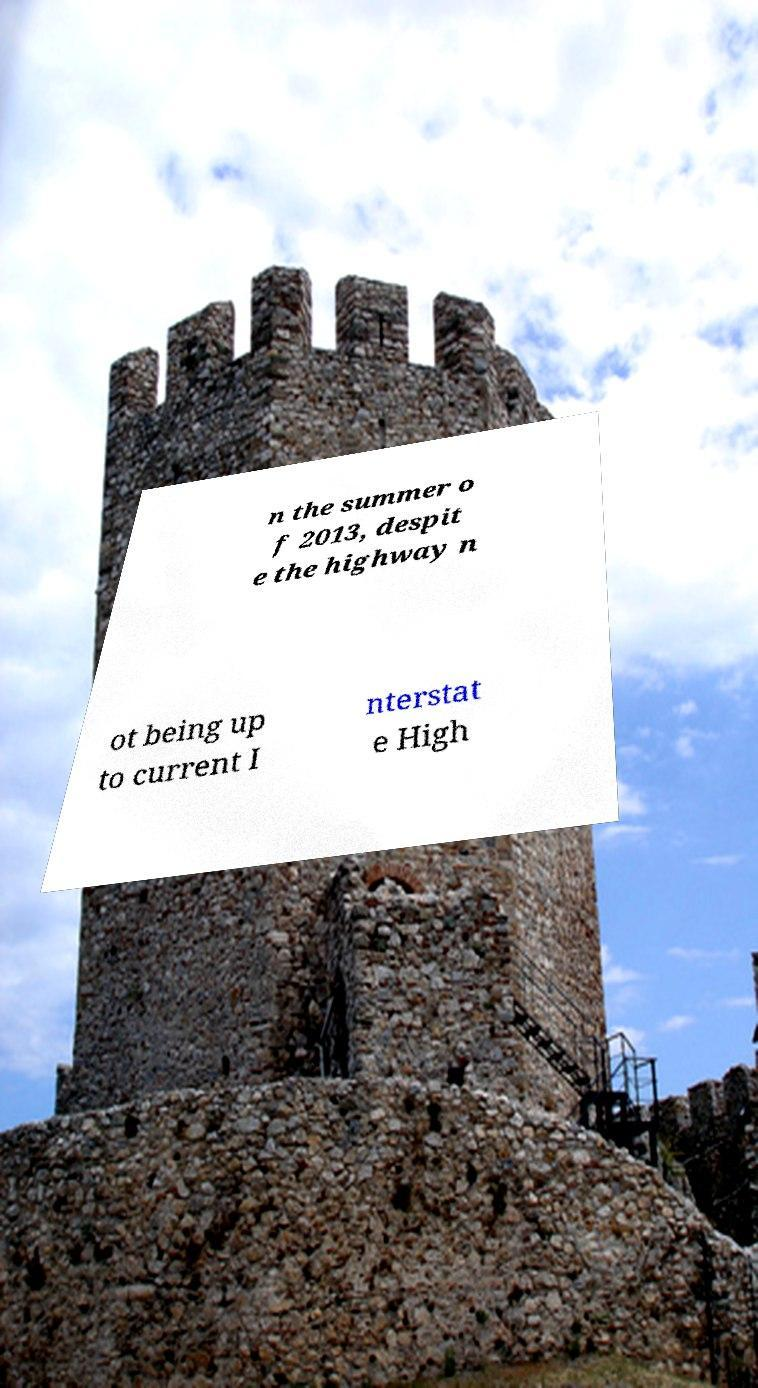For documentation purposes, I need the text within this image transcribed. Could you provide that? n the summer o f 2013, despit e the highway n ot being up to current I nterstat e High 